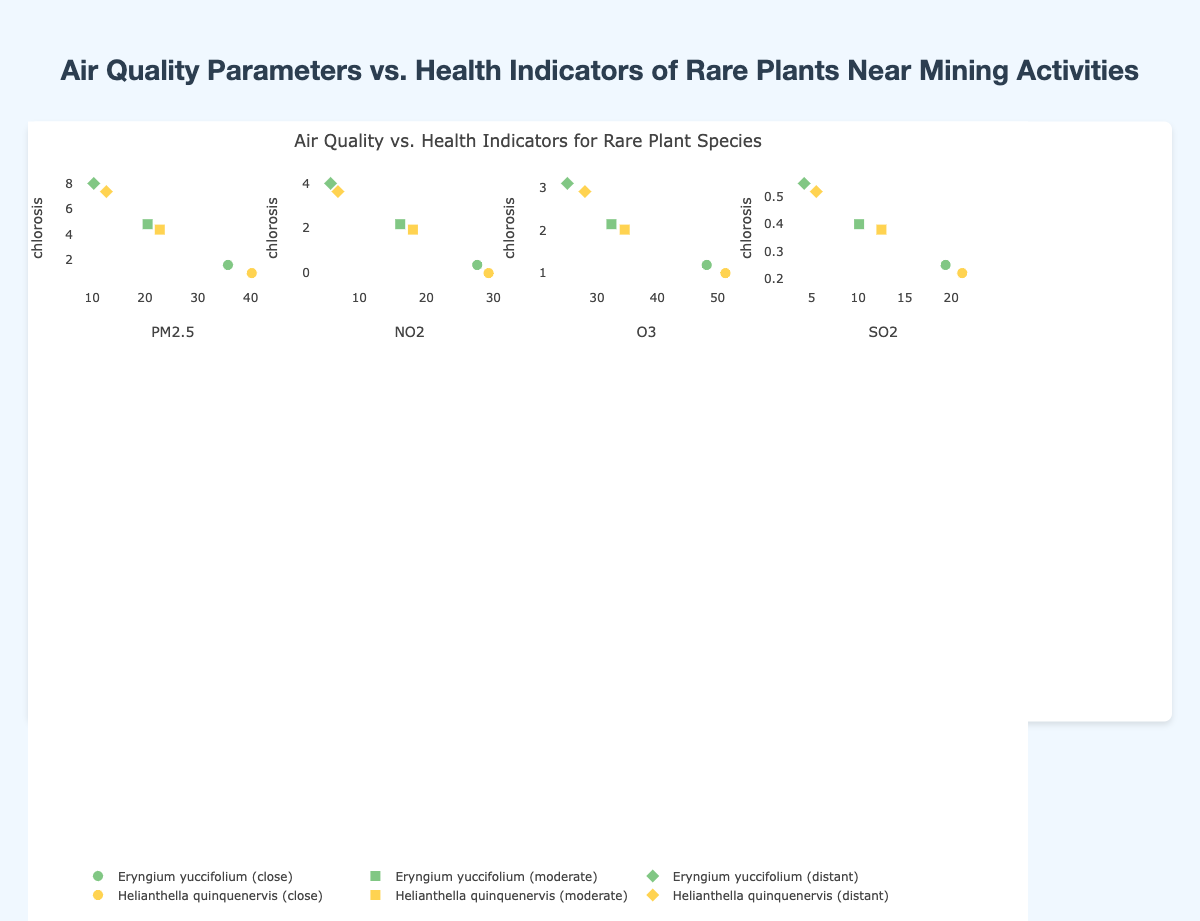What's the title of the chart? The title is clearly displayed at the top of the chart, reading "Air Quality Parameters vs. Health Indicators of Rare Plants Near Mining Activities".
Answer: Air Quality Parameters vs. Health Indicators of Rare Plants Near Mining Activities Which air quality parameter is represented on the x-axis in the first plot of the grid? Each plot in the grid has labeled x-axis and y-axis, and the first plot corresponds to the intersection of the first row and first column. The x-axis label for this plot is "PM2.5".
Answer: PM2.5 Which plant species has the highest "chlorosis" value for the "close" proximity? By looking at the markers representing "Chlorosis" on the y-axis and searching for "close" proximity, the plant species "Helianthella quinquenervis" shows the highest value with a marker (chlorosis: 8).
Answer: Helianthella quinquenervis What is the difference in "NO2" levels between "close" and "distant" proximities for "Eryngium yuccifolium"? The NO2 levels for "Eryngium yuccifolium" at "close" and "distant" proximities are 27.6 and 5.7 respectively. The difference is calculated as 27.6 - 5.7.
Answer: 21.9 How does an increase in "PM2.5" levels correlate with "leaf_area_index" for "Helianthella quinquenervis"? Observing the charts, as "PM2.5" levels decrease from "close" to "distant", the "leaf_area_index" for "Helianthella quinquenervis" increases from 1.0 to 3.0, indicating a negative correlation.
Answer: Negative correlation Which health indicator of "Eryngium yuccifolium" shows a higher variance across different proximities, "necrosis" or "stomatal_conductance"? Checking the y-axis ranges for "necrosis" and "stomatal_conductance", "necrosis" ranges between 0 to 3, and "stomatal_conductance" ranges between 0.25 and 0.55. "Necrosis" is thus more varied in different proximities due to a larger range (0 to 3).
Answer: Necrosis For the "distant" proximity, which plant species exhibits better overall health based on the "leaf_area_index" and "stomatal_conductance"? Comparing the "leaf_area_index" and "stomatal_conductance" values for both species at "distant" proximity, "Eryngium yuccifolium" has 3.1 and 0.55 respectively, and "Helianthella quinquenervis" has 3.0 and 0.52 respectively. "Eryngium yuccifolium" generally performs slightly better.
Answer: Eryngium yuccifolium 